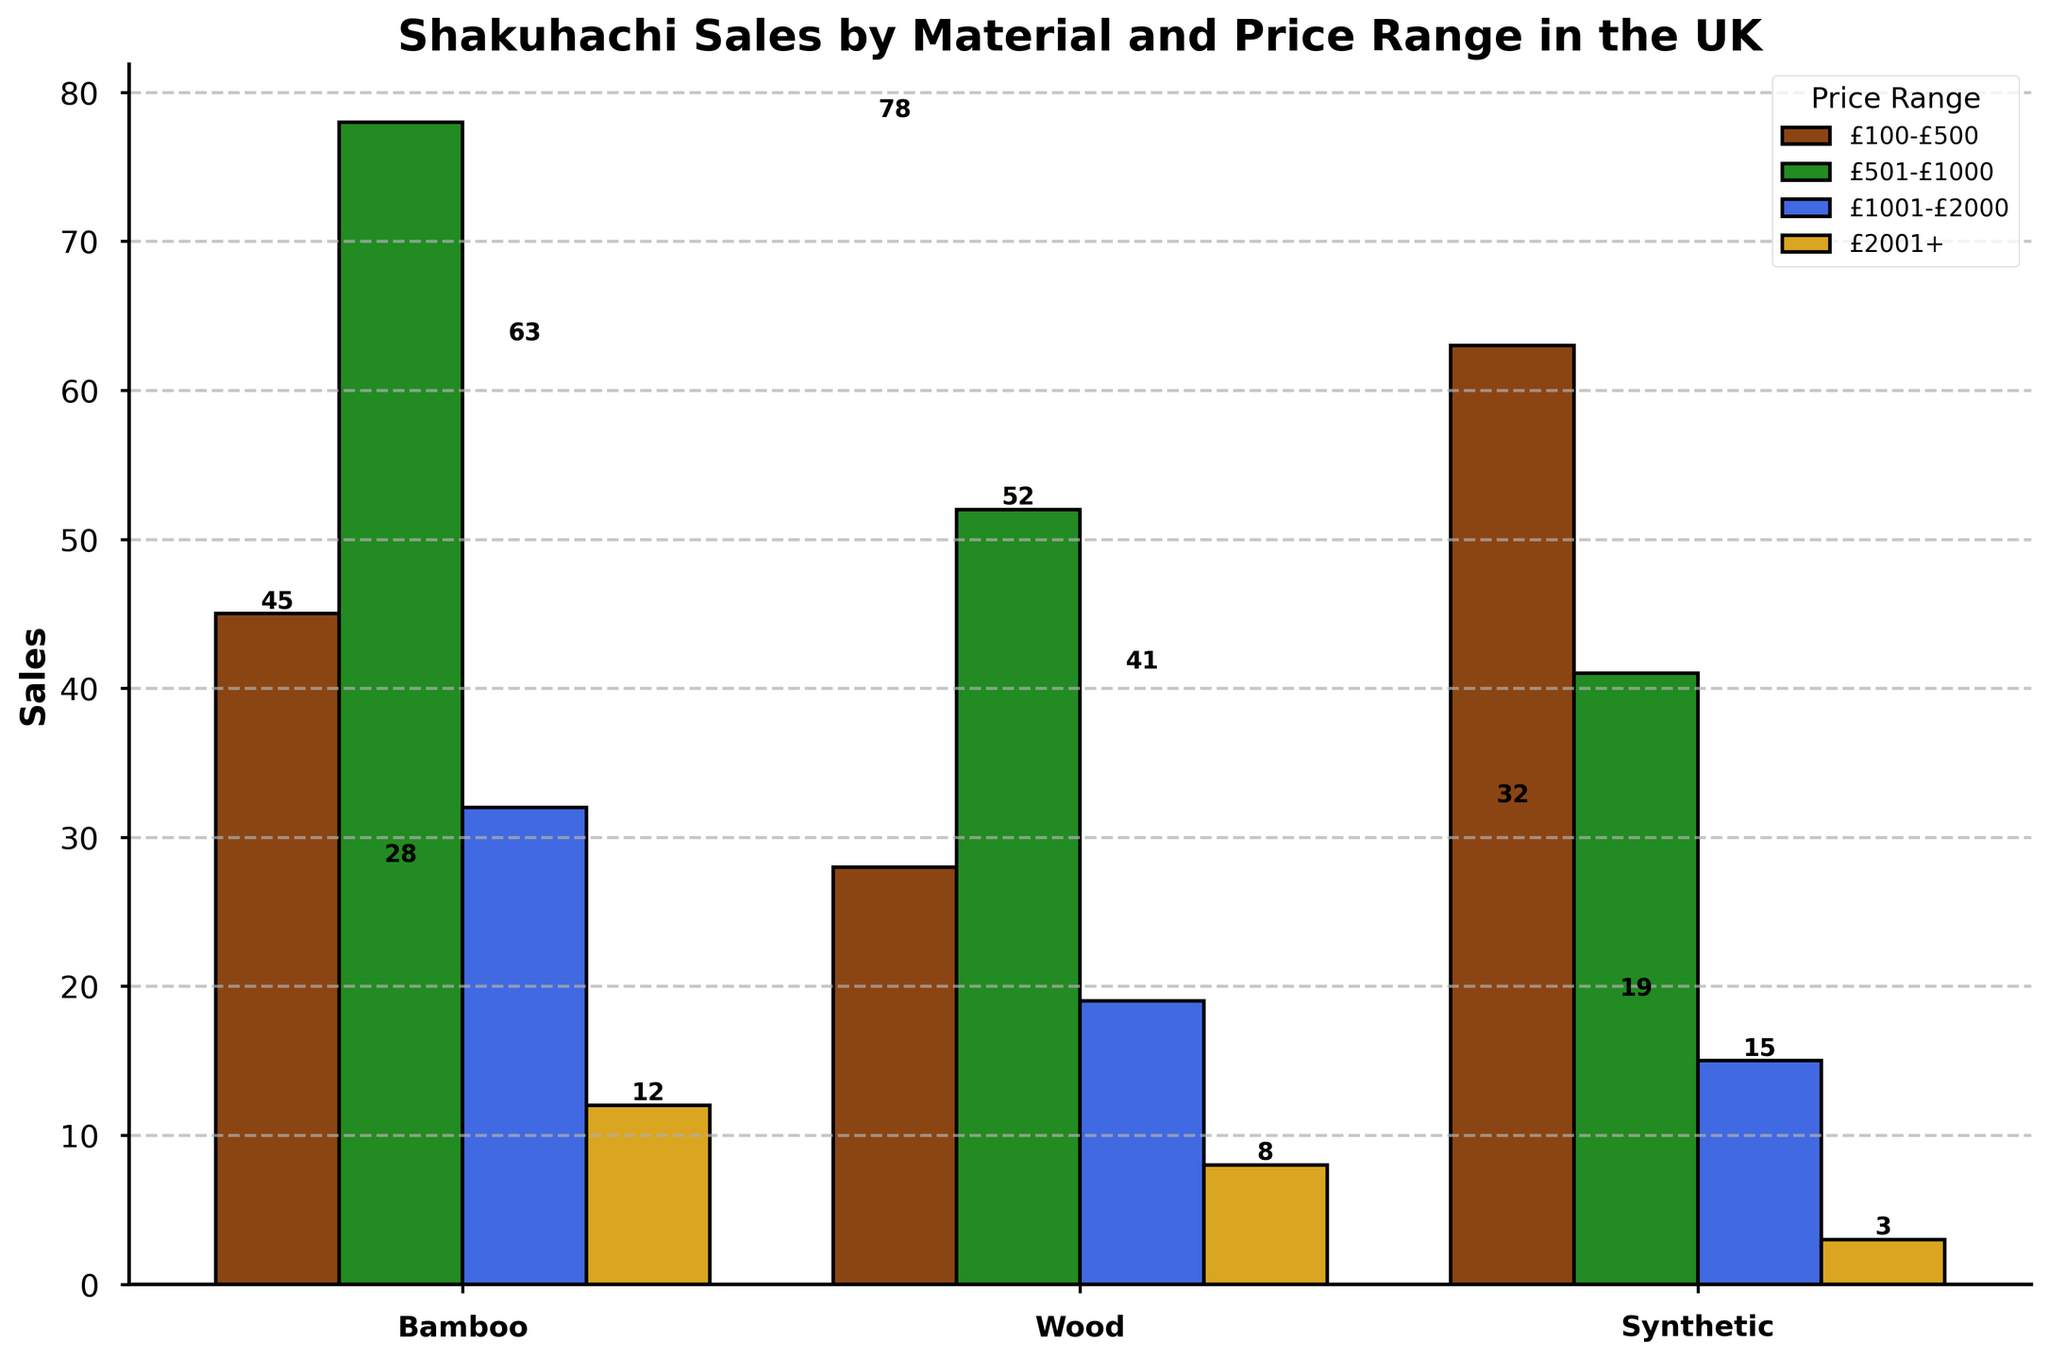How many more Shakuhachi flutes were sold in the £501-£1000 price range compared to the £1001-£2000 price range? First, identify the sales in the £501-£1000 price range for all materials: Bamboo (78), Wood (52), and Synthetic (41); sum them up: 78 + 52 + 41 = 171. Next, identify the sales in the £1001-£2000 price range: Bamboo (32), Wood (19), and Synthetic (15); sum them up: 32 + 19 + 15 = 66. Subtract the totals: 171 - 66 = 105.
Answer: 105 Which material has the highest sales in the £100-£500 price range? Observe the sales numbers in the £100-£500 price range for the materials: Bamboo (45), Wood (28), and Synthetic (63). Synthetic has the highest sales of 63.
Answer: Synthetic What are the total sales for Bamboo Shakuhachi flutes across all price ranges? Identify the sales numbers for Bamboo in all price ranges: £100-£500 (45), £501-£1000 (78), £1001-£2000 (32), and £2001+ (12). Sum these values: 45 + 78 + 32 + 12 = 167.
Answer: 167 Which price range has the highest sales overall? Sum up the sales for each price range across all materials: £100-£500 (Bamboo 45 + Wood 28 + Synthetic 63 = 136), £501-£1000 (Bamboo 78 + Wood 52 + Synthetic 41 = 171), £1001-£2000 (Bamboo 32 + Wood 19 + Synthetic 15 = 66), £2001+ (Bamboo 12 + Wood 8 + Synthetic 3 = 23). The £501-£1000 price range has the highest sales of 171.
Answer: £501-£1000 What is the average number of Shakuhachi flutes sold per material in the £2001+ price range? Identify the sales for each material in the £2001+ price range: Bamboo (12), Wood (8), and Synthetic (3). Sum these sales: 12 + 8 + 3 = 23. There are 3 materials: 23 / 3 = 7.67.
Answer: 7.67 In the £501-£1000 price range, how does the sales figure for Synthetic compare to that for Wood? Compare sales figures in the £501-£1000 range: Synthetic (41) vs. Wood (52). Wood sales are higher than Synthetic sales.
Answer: Wood sales higher What is the difference in total sales between Bamboo and Wood Shakuhachi flutes? Identify the total sales for Bamboo and Wood. Bamboo: (45 + 78 + 32 + 12 = 167), Wood: (28 + 52 + 19 + 8 = 107). Subtract the totals: 167 - 107 = 60.
Answer: 60 What is the least sold material in the £2001+ price range? Compare the sales numbers in the £2001+ price range: Bamboo (12), Wood (8), and Synthetic (3). Synthetic has the lowest sales of 3.
Answer: Synthetic Which material has a sales figure exceeding 40 units in multiple price ranges? Identify materials with sales figures over 40 in multiple ranges. Bamboo exceeds 40 in £501-£1000 (78) and £100-£500 (45); Synthetic exceeds 40 in £100-£500 (63) and £501-£1000 (41). Bamboo does not meet the criteria in multiple ranges, while Synthetic does.
Answer: Synthetic How many Shakuhachi flutes in total were sold in the £100-£500 and £2001+ price ranges combined? Sum total sales for £100-£500 range: Bamboo (45) + Wood (28) + Synthetic (63) = 136. Sum total sales for £2001+ range: Bamboo (12) + Wood (8) + Synthetic (3) = 23. Combine the totals: 136 + 23 = 159.
Answer: 159 